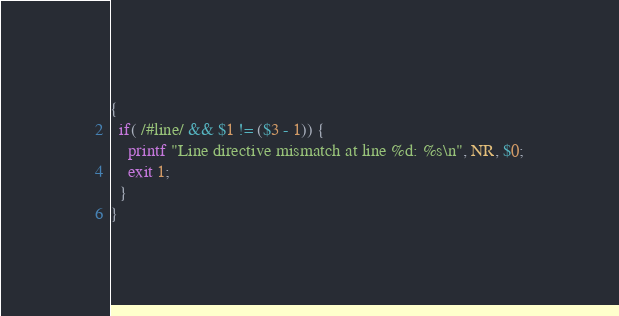<code> <loc_0><loc_0><loc_500><loc_500><_Awk_>{
  if( /#line/ && $1 != ($3 - 1)) {
    printf "Line directive mismatch at line %d: %s\n", NR, $0;
    exit 1;
  }
}

</code> 